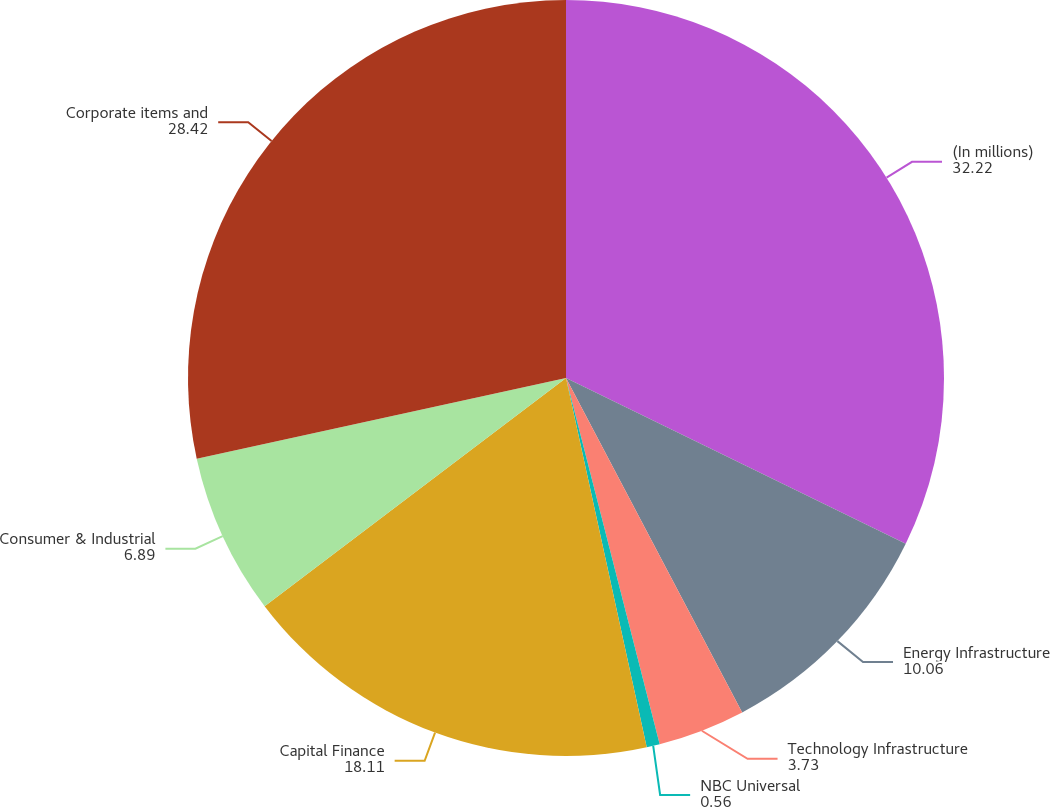Convert chart to OTSL. <chart><loc_0><loc_0><loc_500><loc_500><pie_chart><fcel>(In millions)<fcel>Energy Infrastructure<fcel>Technology Infrastructure<fcel>NBC Universal<fcel>Capital Finance<fcel>Consumer & Industrial<fcel>Corporate items and<nl><fcel>32.22%<fcel>10.06%<fcel>3.73%<fcel>0.56%<fcel>18.11%<fcel>6.89%<fcel>28.42%<nl></chart> 